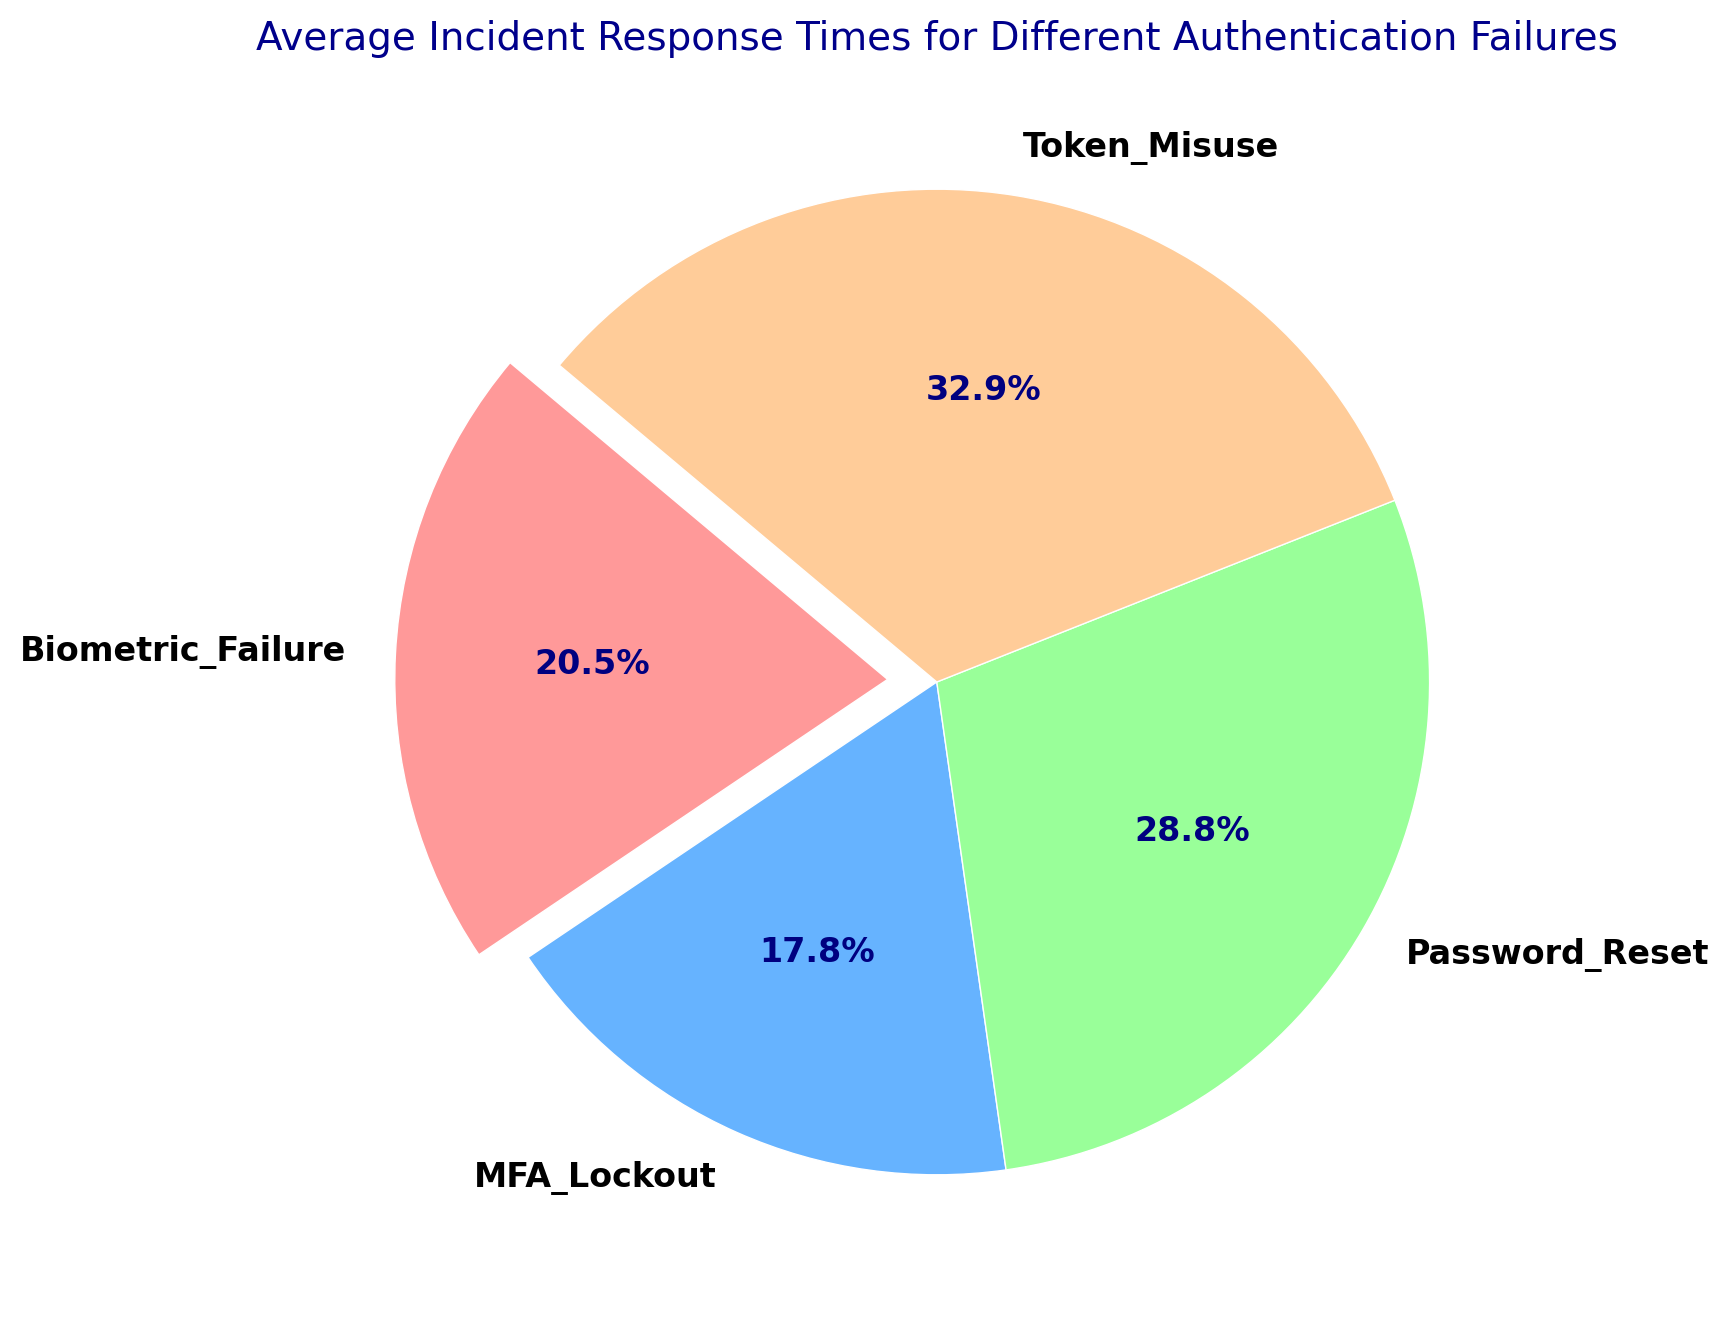How many different types of authentication failures are depicted in the chart? There are four different labels in the pie chart, each representing a different type of authentication failure. Thus, there are four types of authentication failures depicted.
Answer: Four Which authentication failure has the longest average incident response time? By looking at the pie chart, we can see that "Token Misuse" has the biggest wedge or slice, indicating that it has the longest average response time.
Answer: Token Misuse What is the average incident response time for "Password Reset" events? The "Password Reset" section of the pie chart is marked and from the provided data the average incident response time is calculated. Upon inspection, we see that this segment corresponds to the numerical representation shown.
Answer: 52.5 minutes Compare the average incident response time between "MFA Lockout" and "Biometric Failure". Which one is shorter and by how much? From the pie chart, the sizes of the wedges for "MFA Lockout" and "Biometric Failure" can be compared. By calculating the average incidents: "MFA Lockout" has a shorter response time compared to "Biometric Failure".
Answer: MFA Lockout is shorter by 5 minutes What is the sum of the average incident response times for "MFA Lockout" and "Password Reset"? The average response times for "MFA Lockout" and "Password Reset" are indicated in the pie chart. By summing these times (32.5 + 52.5), we can find the desired sum.
Answer: 85 minutes If the total average incident response time is broken down by percentage, what percentage does "Token Misuse" account for? The pie chart sections are annotated with percentage values. The "Token Misuse" section shows the corresponding percentage.
Answer: 34.2% Which color represents 'Biometric Failure' in the pie chart? Observing the color coding in the pie chart, the segment representing "Biometric Failure" can be identified by its distinct color.
Answer: Orange Does any authentication failure type have an average response time less than 30 minutes? If yes, which one? By examining the size of the pie chart wedges and the numerical values, we can confirm if any type has an average response time under 30 minutes.
Answer: No 